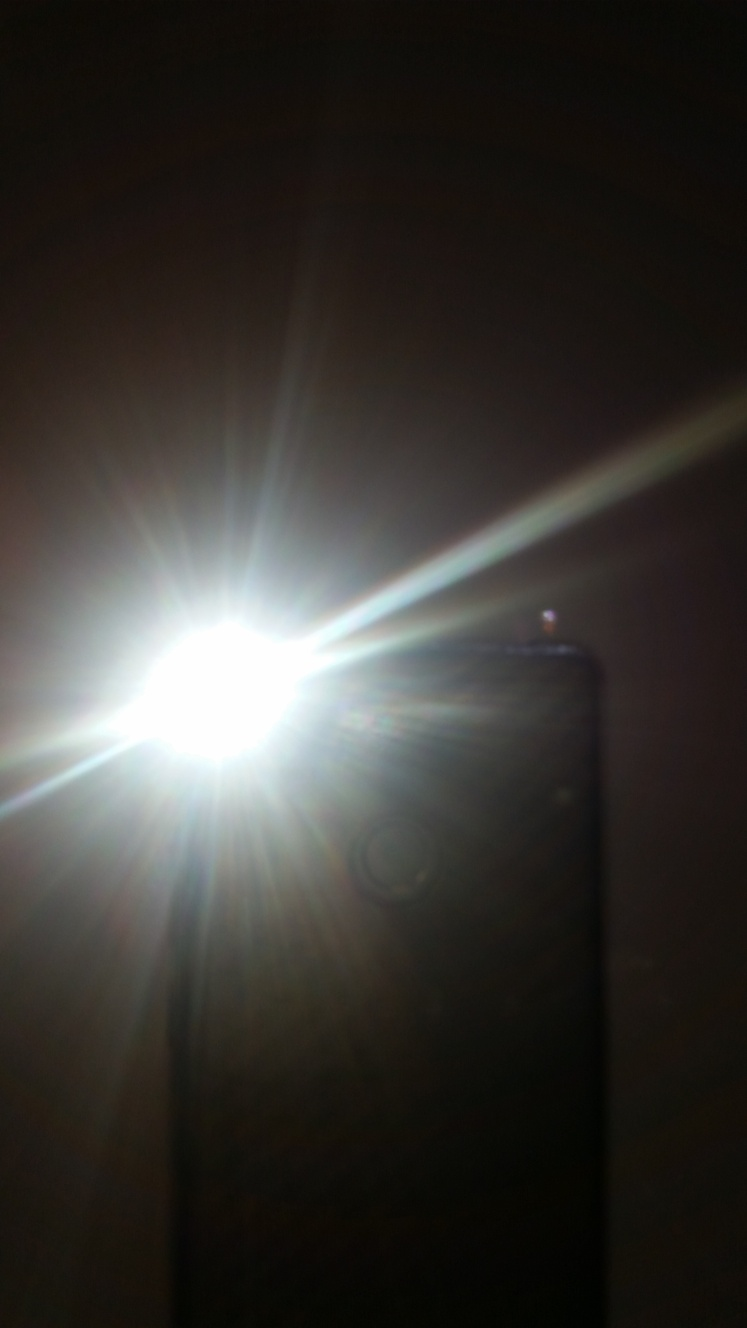What kind of mood does the overexposure stir in this particular image? In this image, the severe overexposure creates a dramatic and intense atmosphere. The stark contrast and the brightness of the light can give a sense of mystery, obscuring details and leaving the viewer curious about what is hidden. It also can impart a dreamlike or otherworldly mood, invoking feelings of transcendence or disorientation. 